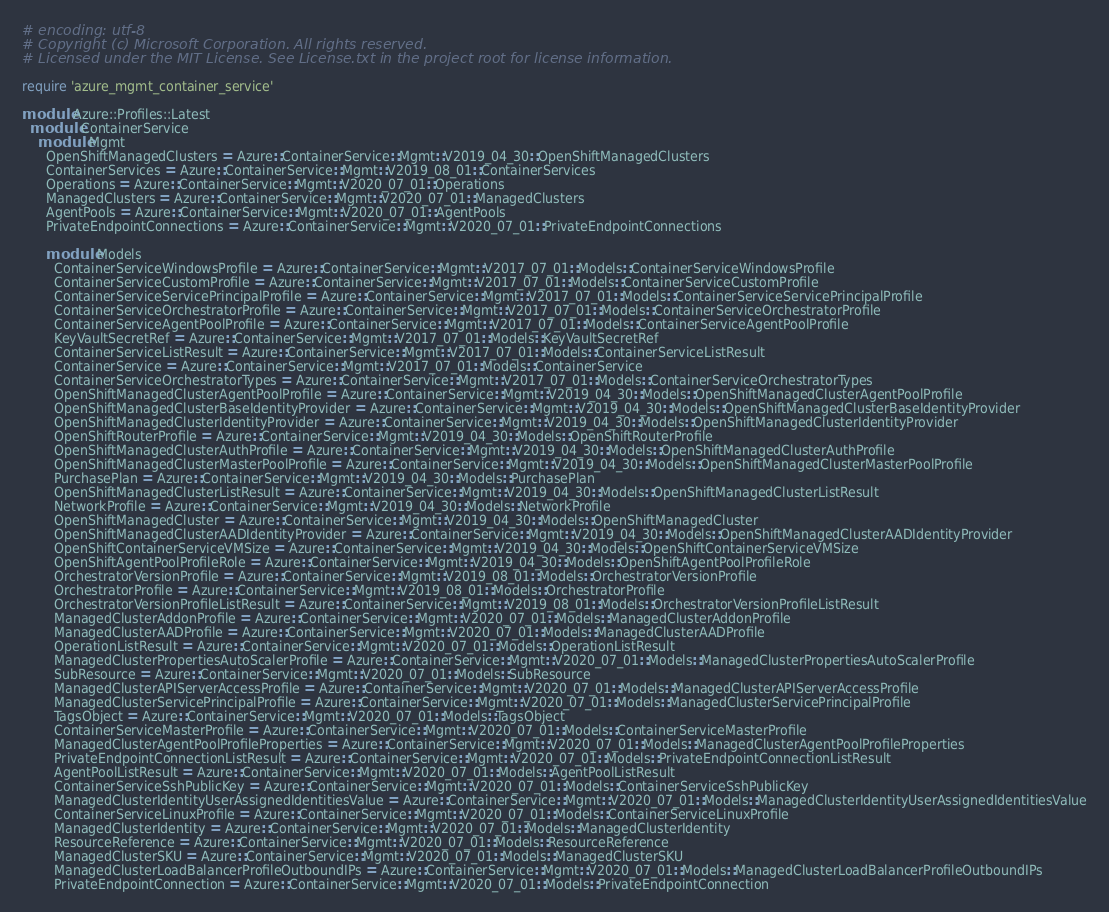<code> <loc_0><loc_0><loc_500><loc_500><_Ruby_># encoding: utf-8
# Copyright (c) Microsoft Corporation. All rights reserved.
# Licensed under the MIT License. See License.txt in the project root for license information.

require 'azure_mgmt_container_service'

module Azure::Profiles::Latest
  module ContainerService
    module Mgmt
      OpenShiftManagedClusters = Azure::ContainerService::Mgmt::V2019_04_30::OpenShiftManagedClusters
      ContainerServices = Azure::ContainerService::Mgmt::V2019_08_01::ContainerServices
      Operations = Azure::ContainerService::Mgmt::V2020_07_01::Operations
      ManagedClusters = Azure::ContainerService::Mgmt::V2020_07_01::ManagedClusters
      AgentPools = Azure::ContainerService::Mgmt::V2020_07_01::AgentPools
      PrivateEndpointConnections = Azure::ContainerService::Mgmt::V2020_07_01::PrivateEndpointConnections

      module Models
        ContainerServiceWindowsProfile = Azure::ContainerService::Mgmt::V2017_07_01::Models::ContainerServiceWindowsProfile
        ContainerServiceCustomProfile = Azure::ContainerService::Mgmt::V2017_07_01::Models::ContainerServiceCustomProfile
        ContainerServiceServicePrincipalProfile = Azure::ContainerService::Mgmt::V2017_07_01::Models::ContainerServiceServicePrincipalProfile
        ContainerServiceOrchestratorProfile = Azure::ContainerService::Mgmt::V2017_07_01::Models::ContainerServiceOrchestratorProfile
        ContainerServiceAgentPoolProfile = Azure::ContainerService::Mgmt::V2017_07_01::Models::ContainerServiceAgentPoolProfile
        KeyVaultSecretRef = Azure::ContainerService::Mgmt::V2017_07_01::Models::KeyVaultSecretRef
        ContainerServiceListResult = Azure::ContainerService::Mgmt::V2017_07_01::Models::ContainerServiceListResult
        ContainerService = Azure::ContainerService::Mgmt::V2017_07_01::Models::ContainerService
        ContainerServiceOrchestratorTypes = Azure::ContainerService::Mgmt::V2017_07_01::Models::ContainerServiceOrchestratorTypes
        OpenShiftManagedClusterAgentPoolProfile = Azure::ContainerService::Mgmt::V2019_04_30::Models::OpenShiftManagedClusterAgentPoolProfile
        OpenShiftManagedClusterBaseIdentityProvider = Azure::ContainerService::Mgmt::V2019_04_30::Models::OpenShiftManagedClusterBaseIdentityProvider
        OpenShiftManagedClusterIdentityProvider = Azure::ContainerService::Mgmt::V2019_04_30::Models::OpenShiftManagedClusterIdentityProvider
        OpenShiftRouterProfile = Azure::ContainerService::Mgmt::V2019_04_30::Models::OpenShiftRouterProfile
        OpenShiftManagedClusterAuthProfile = Azure::ContainerService::Mgmt::V2019_04_30::Models::OpenShiftManagedClusterAuthProfile
        OpenShiftManagedClusterMasterPoolProfile = Azure::ContainerService::Mgmt::V2019_04_30::Models::OpenShiftManagedClusterMasterPoolProfile
        PurchasePlan = Azure::ContainerService::Mgmt::V2019_04_30::Models::PurchasePlan
        OpenShiftManagedClusterListResult = Azure::ContainerService::Mgmt::V2019_04_30::Models::OpenShiftManagedClusterListResult
        NetworkProfile = Azure::ContainerService::Mgmt::V2019_04_30::Models::NetworkProfile
        OpenShiftManagedCluster = Azure::ContainerService::Mgmt::V2019_04_30::Models::OpenShiftManagedCluster
        OpenShiftManagedClusterAADIdentityProvider = Azure::ContainerService::Mgmt::V2019_04_30::Models::OpenShiftManagedClusterAADIdentityProvider
        OpenShiftContainerServiceVMSize = Azure::ContainerService::Mgmt::V2019_04_30::Models::OpenShiftContainerServiceVMSize
        OpenShiftAgentPoolProfileRole = Azure::ContainerService::Mgmt::V2019_04_30::Models::OpenShiftAgentPoolProfileRole
        OrchestratorVersionProfile = Azure::ContainerService::Mgmt::V2019_08_01::Models::OrchestratorVersionProfile
        OrchestratorProfile = Azure::ContainerService::Mgmt::V2019_08_01::Models::OrchestratorProfile
        OrchestratorVersionProfileListResult = Azure::ContainerService::Mgmt::V2019_08_01::Models::OrchestratorVersionProfileListResult
        ManagedClusterAddonProfile = Azure::ContainerService::Mgmt::V2020_07_01::Models::ManagedClusterAddonProfile
        ManagedClusterAADProfile = Azure::ContainerService::Mgmt::V2020_07_01::Models::ManagedClusterAADProfile
        OperationListResult = Azure::ContainerService::Mgmt::V2020_07_01::Models::OperationListResult
        ManagedClusterPropertiesAutoScalerProfile = Azure::ContainerService::Mgmt::V2020_07_01::Models::ManagedClusterPropertiesAutoScalerProfile
        SubResource = Azure::ContainerService::Mgmt::V2020_07_01::Models::SubResource
        ManagedClusterAPIServerAccessProfile = Azure::ContainerService::Mgmt::V2020_07_01::Models::ManagedClusterAPIServerAccessProfile
        ManagedClusterServicePrincipalProfile = Azure::ContainerService::Mgmt::V2020_07_01::Models::ManagedClusterServicePrincipalProfile
        TagsObject = Azure::ContainerService::Mgmt::V2020_07_01::Models::TagsObject
        ContainerServiceMasterProfile = Azure::ContainerService::Mgmt::V2020_07_01::Models::ContainerServiceMasterProfile
        ManagedClusterAgentPoolProfileProperties = Azure::ContainerService::Mgmt::V2020_07_01::Models::ManagedClusterAgentPoolProfileProperties
        PrivateEndpointConnectionListResult = Azure::ContainerService::Mgmt::V2020_07_01::Models::PrivateEndpointConnectionListResult
        AgentPoolListResult = Azure::ContainerService::Mgmt::V2020_07_01::Models::AgentPoolListResult
        ContainerServiceSshPublicKey = Azure::ContainerService::Mgmt::V2020_07_01::Models::ContainerServiceSshPublicKey
        ManagedClusterIdentityUserAssignedIdentitiesValue = Azure::ContainerService::Mgmt::V2020_07_01::Models::ManagedClusterIdentityUserAssignedIdentitiesValue
        ContainerServiceLinuxProfile = Azure::ContainerService::Mgmt::V2020_07_01::Models::ContainerServiceLinuxProfile
        ManagedClusterIdentity = Azure::ContainerService::Mgmt::V2020_07_01::Models::ManagedClusterIdentity
        ResourceReference = Azure::ContainerService::Mgmt::V2020_07_01::Models::ResourceReference
        ManagedClusterSKU = Azure::ContainerService::Mgmt::V2020_07_01::Models::ManagedClusterSKU
        ManagedClusterLoadBalancerProfileOutboundIPs = Azure::ContainerService::Mgmt::V2020_07_01::Models::ManagedClusterLoadBalancerProfileOutboundIPs
        PrivateEndpointConnection = Azure::ContainerService::Mgmt::V2020_07_01::Models::PrivateEndpointConnection</code> 